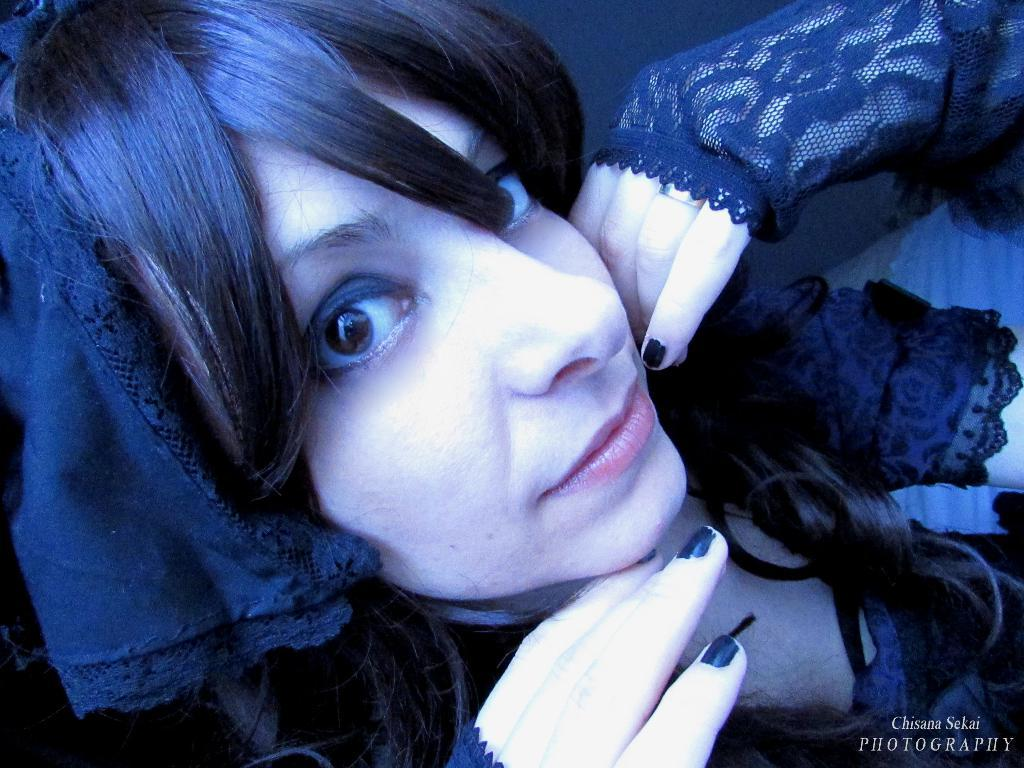Who is present in the image? There is a woman in the image. What is the woman wearing? The woman is wearing a black dress. Is there any text or marking in the image? Yes, there is a watermark in the bottom right corner of the image. What type of pot is the woman holding in the image? There is no pot present in the image; the woman is not holding anything. How many yams can be seen in the image? There are no yams present in the image. 